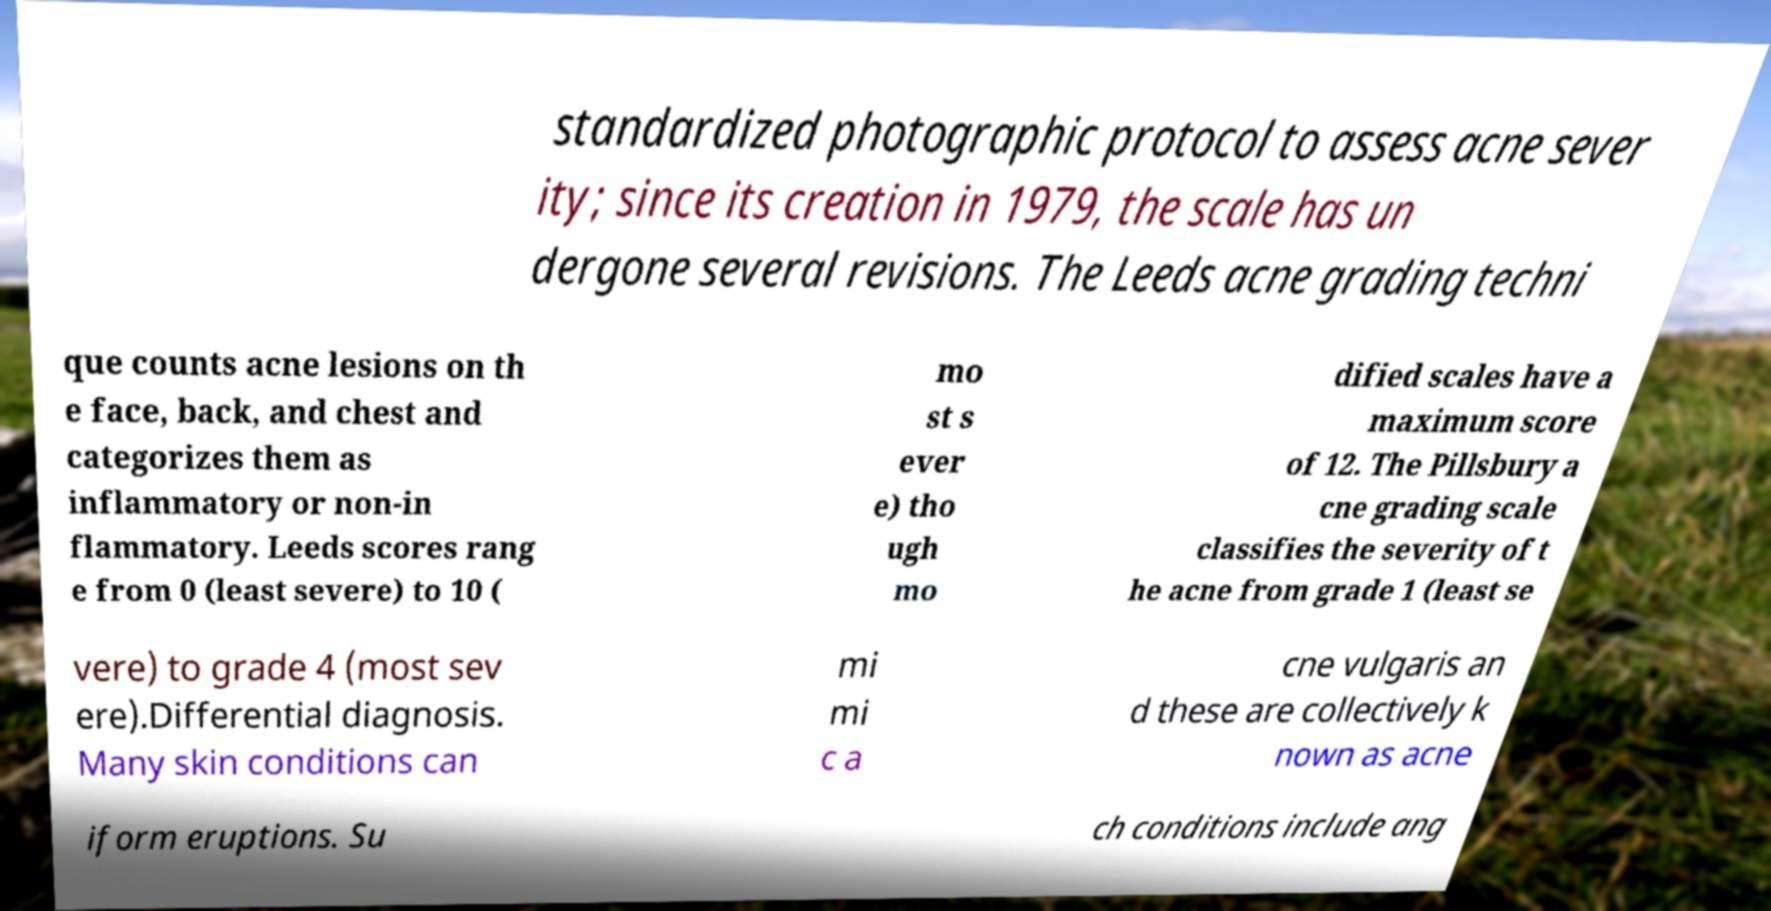I need the written content from this picture converted into text. Can you do that? standardized photographic protocol to assess acne sever ity; since its creation in 1979, the scale has un dergone several revisions. The Leeds acne grading techni que counts acne lesions on th e face, back, and chest and categorizes them as inflammatory or non-in flammatory. Leeds scores rang e from 0 (least severe) to 10 ( mo st s ever e) tho ugh mo dified scales have a maximum score of 12. The Pillsbury a cne grading scale classifies the severity of t he acne from grade 1 (least se vere) to grade 4 (most sev ere).Differential diagnosis. Many skin conditions can mi mi c a cne vulgaris an d these are collectively k nown as acne iform eruptions. Su ch conditions include ang 